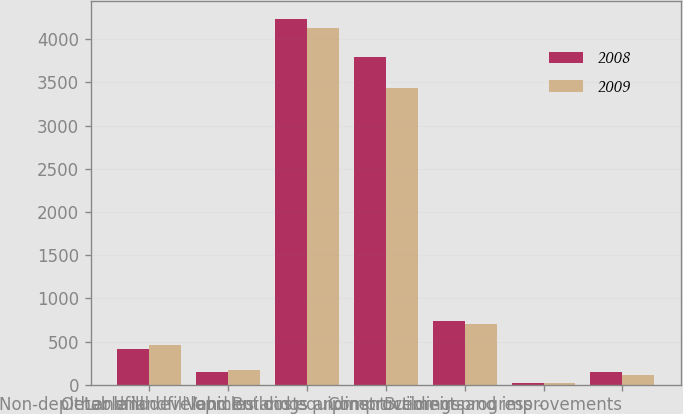Convert chart. <chart><loc_0><loc_0><loc_500><loc_500><stacked_bar_chart><ecel><fcel>Other land<fcel>Non-depletable landfill land<fcel>Landfill development costs<fcel>Vehicles and equipment<fcel>Buildings andimprovements<fcel>Construction-in-progress -<fcel>Buildings and improvements<nl><fcel>2008<fcel>418.7<fcel>142.7<fcel>4230.9<fcel>3792.4<fcel>741.6<fcel>23<fcel>143.1<nl><fcel>2009<fcel>464.4<fcel>169.3<fcel>4126.3<fcel>3432.3<fcel>706<fcel>26.3<fcel>111.1<nl></chart> 